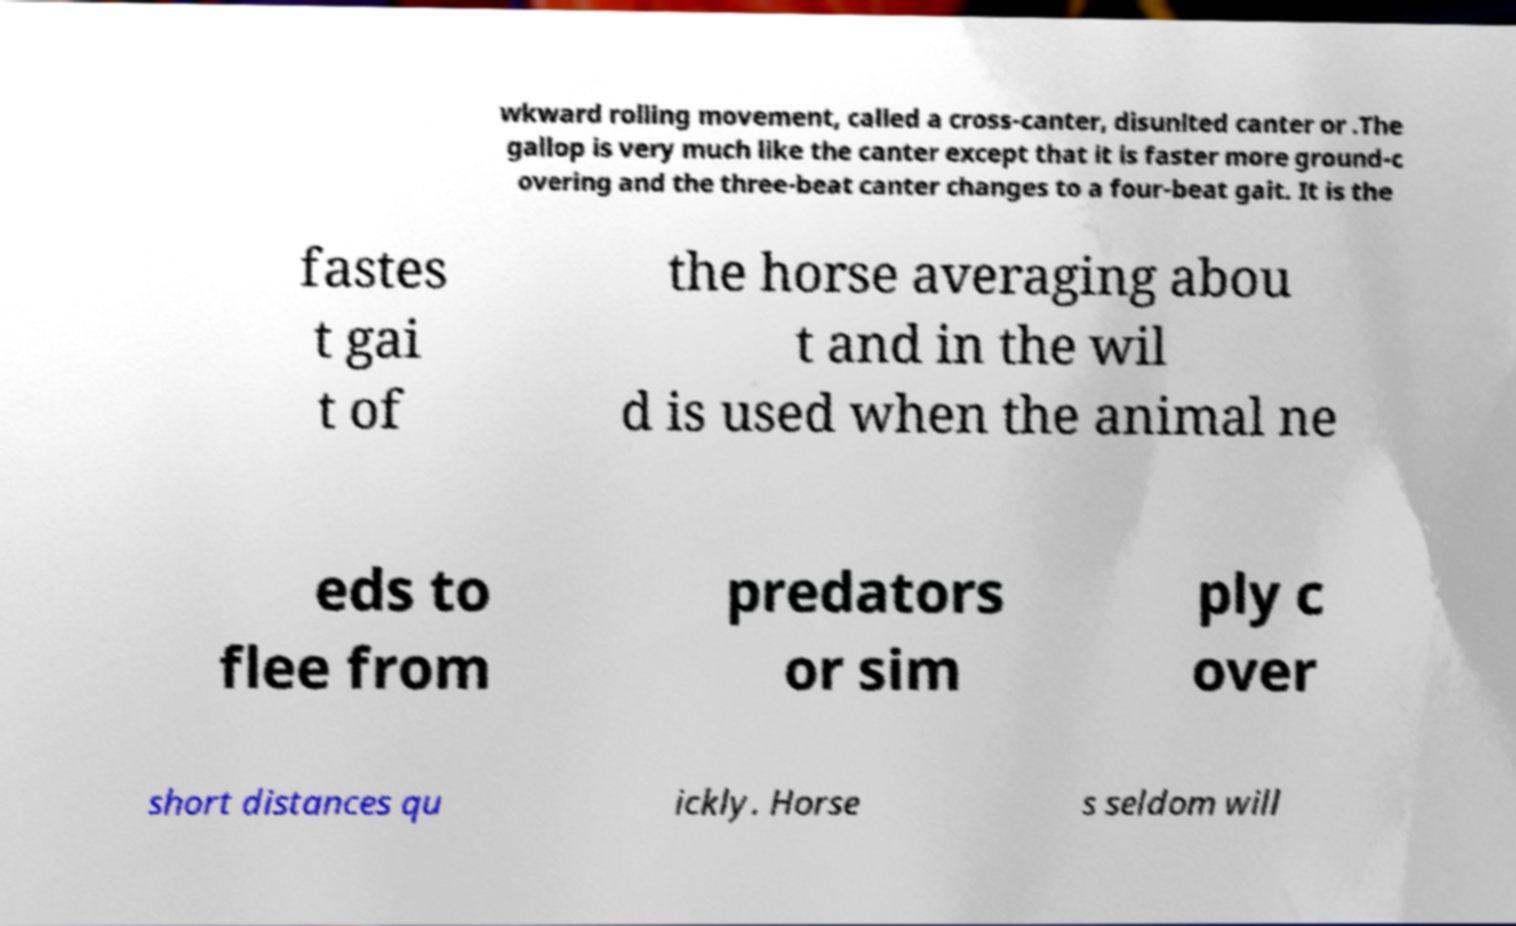There's text embedded in this image that I need extracted. Can you transcribe it verbatim? wkward rolling movement, called a cross-canter, disunited canter or .The gallop is very much like the canter except that it is faster more ground-c overing and the three-beat canter changes to a four-beat gait. It is the fastes t gai t of the horse averaging abou t and in the wil d is used when the animal ne eds to flee from predators or sim ply c over short distances qu ickly. Horse s seldom will 